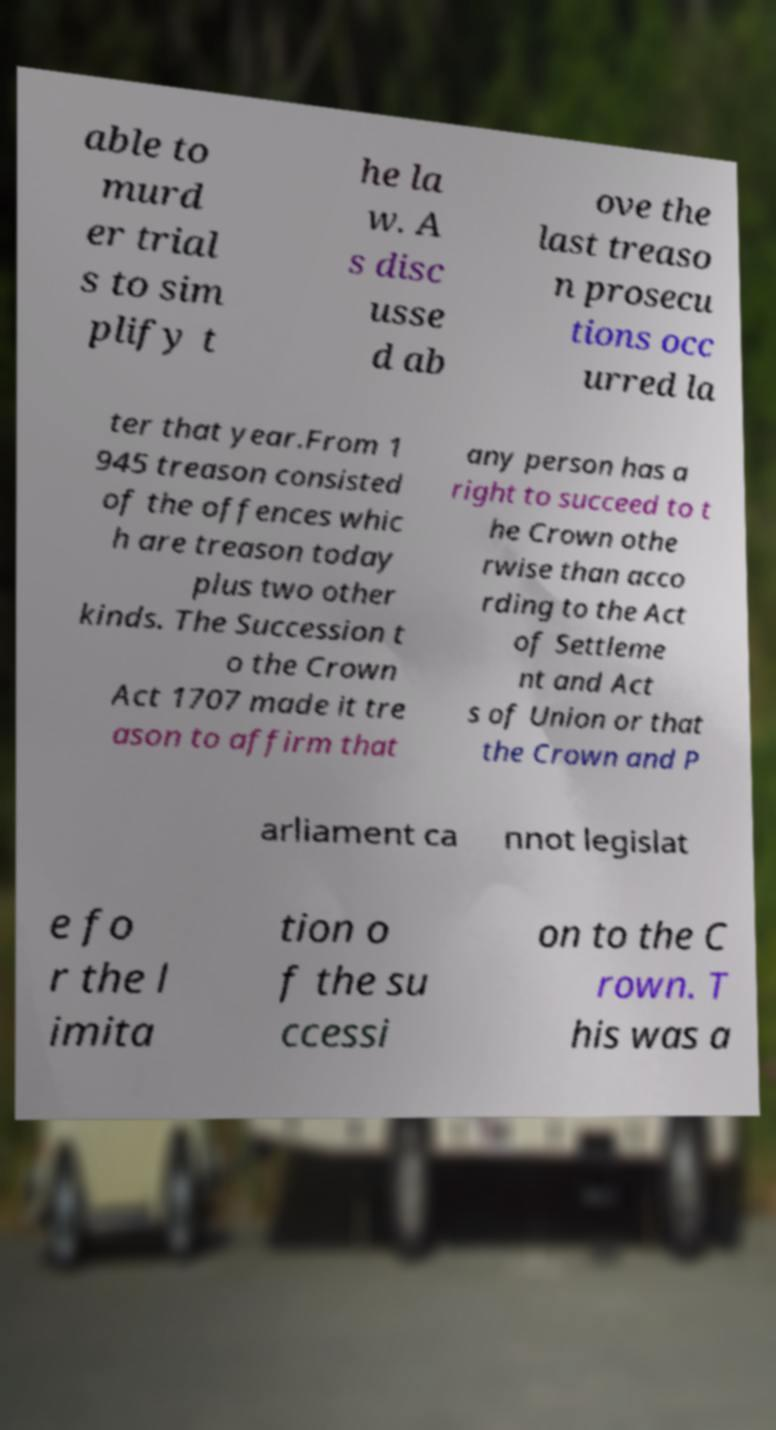Please read and relay the text visible in this image. What does it say? able to murd er trial s to sim plify t he la w. A s disc usse d ab ove the last treaso n prosecu tions occ urred la ter that year.From 1 945 treason consisted of the offences whic h are treason today plus two other kinds. The Succession t o the Crown Act 1707 made it tre ason to affirm that any person has a right to succeed to t he Crown othe rwise than acco rding to the Act of Settleme nt and Act s of Union or that the Crown and P arliament ca nnot legislat e fo r the l imita tion o f the su ccessi on to the C rown. T his was a 